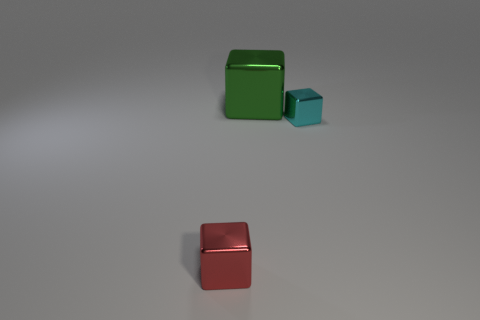Add 1 tiny red shiny cubes. How many objects exist? 4 Add 3 green metal cubes. How many green metal cubes exist? 4 Subtract 0 green balls. How many objects are left? 3 Subtract all cyan metal objects. Subtract all big objects. How many objects are left? 1 Add 3 big things. How many big things are left? 4 